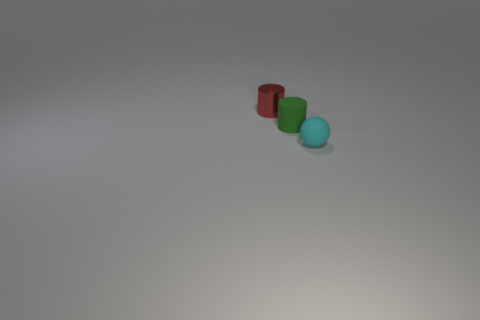Add 3 shiny things. How many objects exist? 6 Subtract 0 cyan cubes. How many objects are left? 3 Subtract all cylinders. How many objects are left? 1 Subtract all brown balls. Subtract all cyan cylinders. How many balls are left? 1 Subtract all small cyan metal cubes. Subtract all red things. How many objects are left? 2 Add 1 small red shiny cylinders. How many small red shiny cylinders are left? 2 Add 2 green matte cylinders. How many green matte cylinders exist? 3 